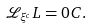Convert formula to latex. <formula><loc_0><loc_0><loc_500><loc_500>\mathcal { L } _ { \xi ^ { c } } L = 0 C .</formula> 